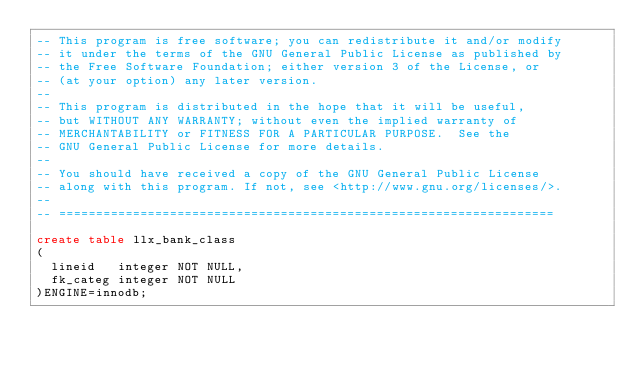Convert code to text. <code><loc_0><loc_0><loc_500><loc_500><_SQL_>-- This program is free software; you can redistribute it and/or modify
-- it under the terms of the GNU General Public License as published by
-- the Free Software Foundation; either version 3 of the License, or
-- (at your option) any later version.
--
-- This program is distributed in the hope that it will be useful,
-- but WITHOUT ANY WARRANTY; without even the implied warranty of
-- MERCHANTABILITY or FITNESS FOR A PARTICULAR PURPOSE.  See the
-- GNU General Public License for more details.
--
-- You should have received a copy of the GNU General Public License
-- along with this program. If not, see <http://www.gnu.org/licenses/>.
--
-- ===================================================================

create table llx_bank_class
(
  lineid   integer NOT NULL,
  fk_categ integer NOT NULL
)ENGINE=innodb;
</code> 